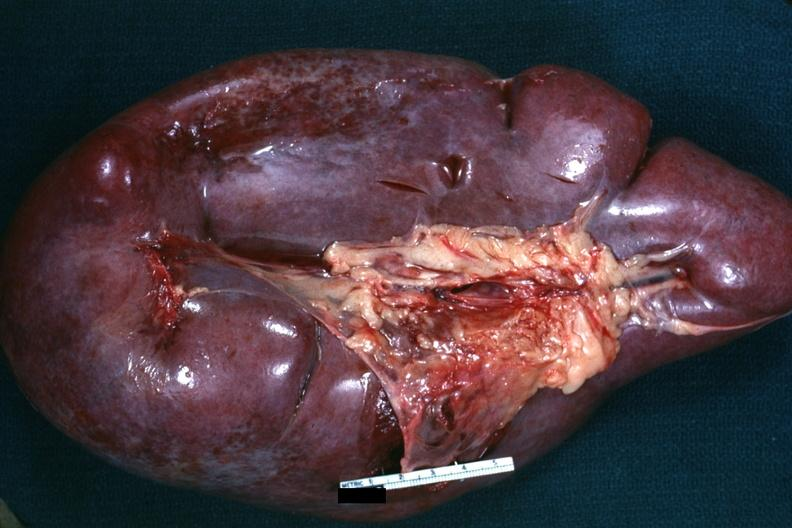what is present?
Answer the question using a single word or phrase. Hematologic 